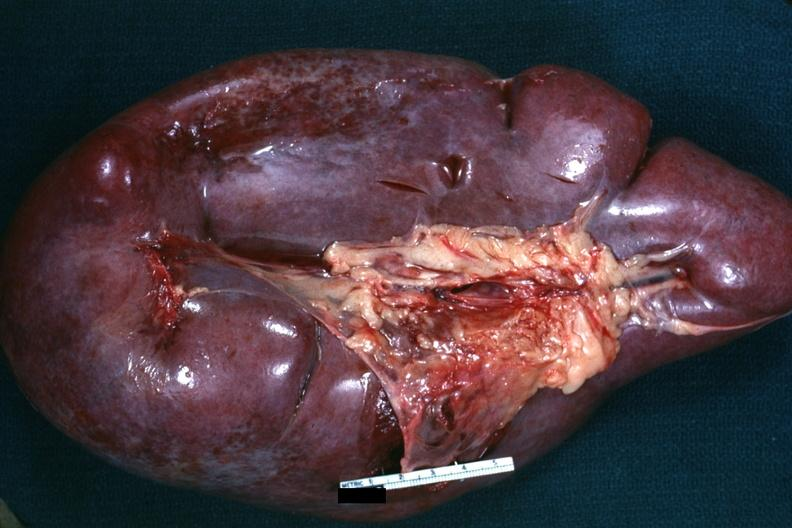what is present?
Answer the question using a single word or phrase. Hematologic 